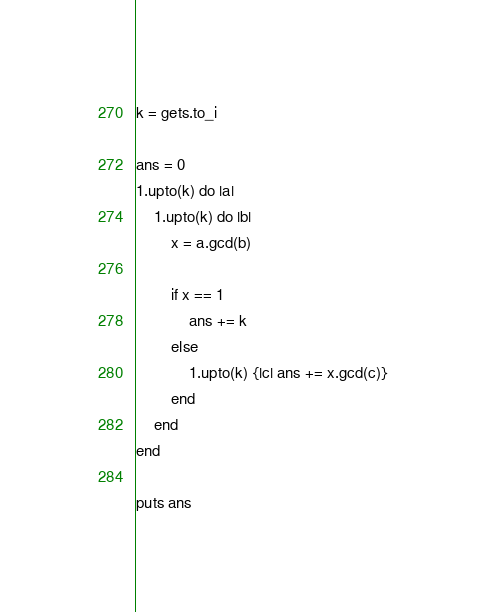<code> <loc_0><loc_0><loc_500><loc_500><_Ruby_>k = gets.to_i

ans = 0
1.upto(k) do |a|
    1.upto(k) do |b|
        x = a.gcd(b)
        
        if x == 1
            ans += k
        else
            1.upto(k) {|c| ans += x.gcd(c)}
        end
    end
end

puts ans</code> 